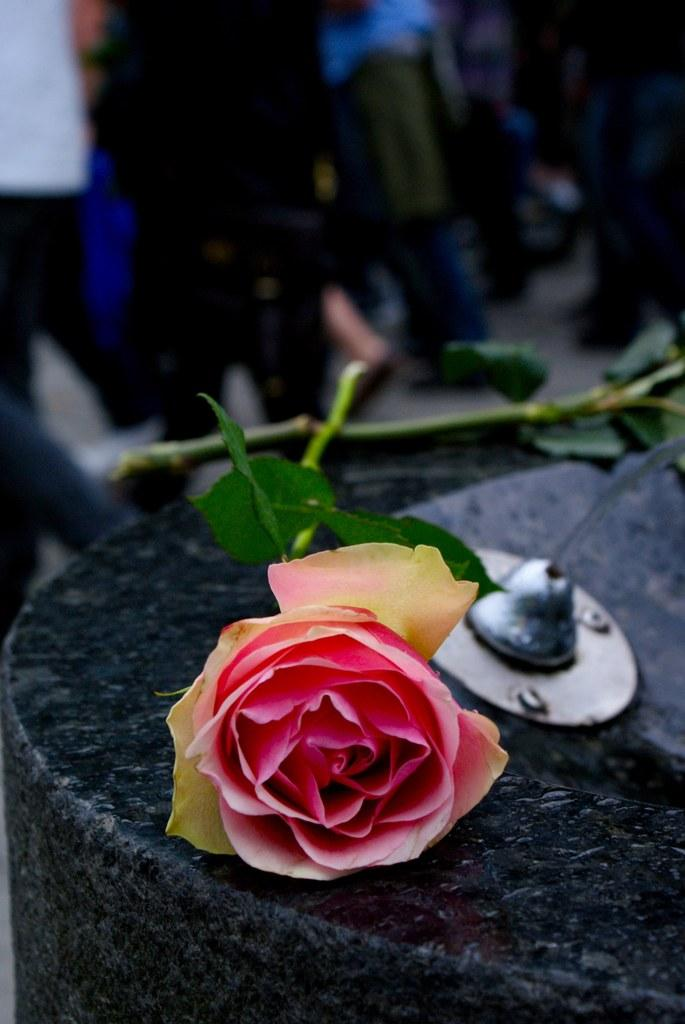What type of flowers are on the stone wall in the image? There are two roses on the stone wall in the image. What material is the object in the image made of? The object in the image is made of metal. Can you describe the people visible in the image? Unfortunately, the facts provided do not give any information about the people in the image. What type of company is mentioned in the note on the stone wall? There is no note present on the stone wall in the image, so it is not possible to answer that question. What type of plantation is visible in the image? There is no plantation visible in the image; it features a stone wall with two roses and a metal object. 